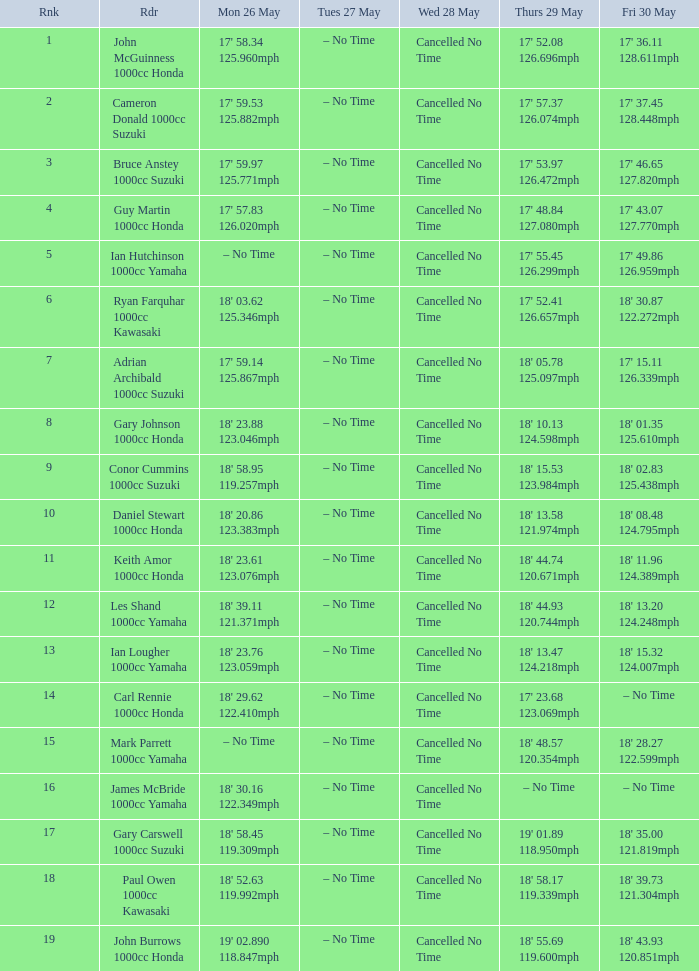What is the numbr for fri may 30 and mon may 26 is 19' 02.890 118.847mph? 18' 43.93 120.851mph. 